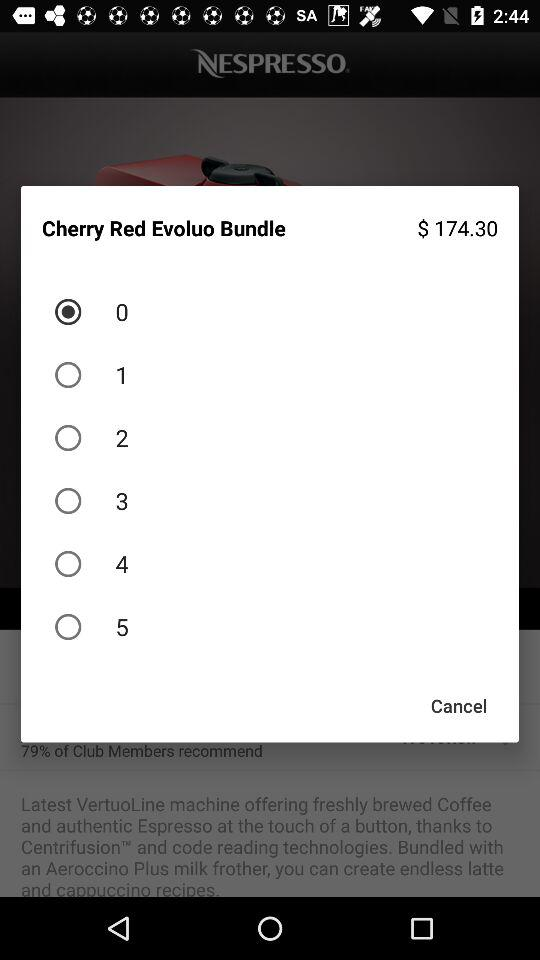What is the name of the application? The name of the application is "NESPRESSO". 